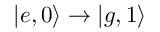<formula> <loc_0><loc_0><loc_500><loc_500>\left | e , 0 \right \rangle \rightarrow \left | g , 1 \right \rangle</formula> 